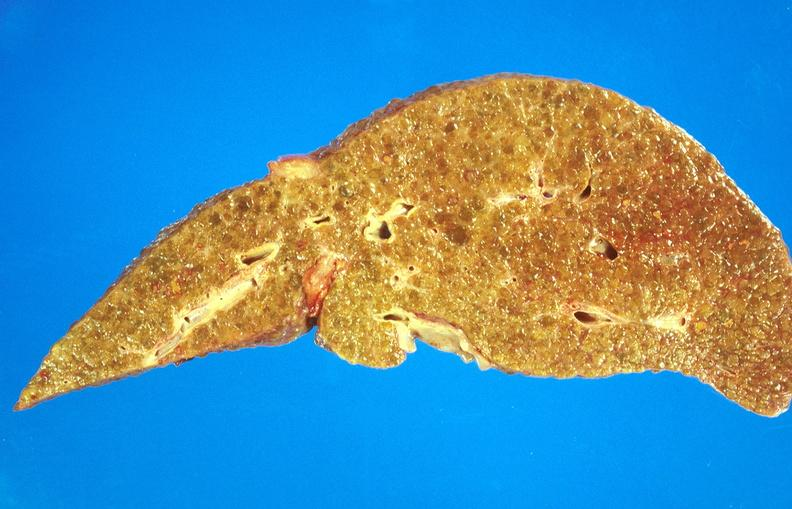s small intestine present?
Answer the question using a single word or phrase. No 